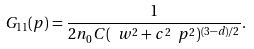Convert formula to latex. <formula><loc_0><loc_0><loc_500><loc_500>G _ { 1 1 } ( p ) = \frac { 1 } { 2 n _ { 0 } C ( \ w ^ { 2 } + c ^ { 2 } \ p ^ { 2 } ) ^ { ( 3 - d ) / 2 } } .</formula> 